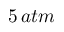<formula> <loc_0><loc_0><loc_500><loc_500>5 \, a t m</formula> 